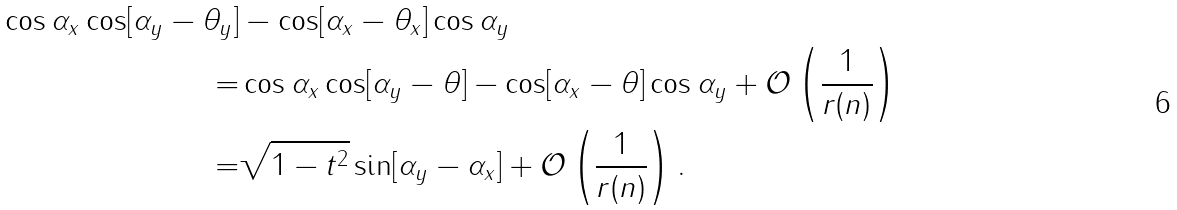<formula> <loc_0><loc_0><loc_500><loc_500>\cos \alpha _ { x } \cos [ \alpha _ { y } - \theta _ { y } ] & - \cos [ \alpha _ { x } - \theta _ { x } ] \cos \alpha _ { y } \\ = & \cos \alpha _ { x } \cos [ \alpha _ { y } - \theta ] - \cos [ \alpha _ { x } - \theta ] \cos \alpha _ { y } + \mathcal { O } \left ( \frac { 1 } { r ( n ) } \right ) \\ = & \sqrt { 1 - t ^ { 2 } } \sin [ \alpha _ { y } - \alpha _ { x } ] + \mathcal { O } \left ( \frac { 1 } { r ( n ) } \right ) .</formula> 